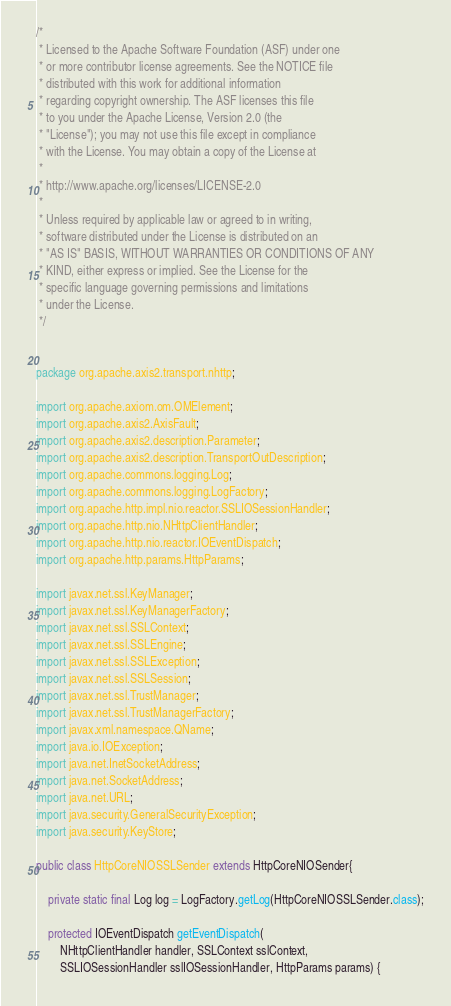<code> <loc_0><loc_0><loc_500><loc_500><_Java_>
/*
 * Licensed to the Apache Software Foundation (ASF) under one
 * or more contributor license agreements. See the NOTICE file
 * distributed with this work for additional information
 * regarding copyright ownership. The ASF licenses this file
 * to you under the Apache License, Version 2.0 (the
 * "License"); you may not use this file except in compliance
 * with the License. You may obtain a copy of the License at
 *
 * http://www.apache.org/licenses/LICENSE-2.0
 *
 * Unless required by applicable law or agreed to in writing,
 * software distributed under the License is distributed on an
 * "AS IS" BASIS, WITHOUT WARRANTIES OR CONDITIONS OF ANY
 * KIND, either express or implied. See the License for the
 * specific language governing permissions and limitations
 * under the License.
 */


package org.apache.axis2.transport.nhttp;

import org.apache.axiom.om.OMElement;
import org.apache.axis2.AxisFault;
import org.apache.axis2.description.Parameter;
import org.apache.axis2.description.TransportOutDescription;
import org.apache.commons.logging.Log;
import org.apache.commons.logging.LogFactory;
import org.apache.http.impl.nio.reactor.SSLIOSessionHandler;
import org.apache.http.nio.NHttpClientHandler;
import org.apache.http.nio.reactor.IOEventDispatch;
import org.apache.http.params.HttpParams;

import javax.net.ssl.KeyManager;
import javax.net.ssl.KeyManagerFactory;
import javax.net.ssl.SSLContext;
import javax.net.ssl.SSLEngine;
import javax.net.ssl.SSLException;
import javax.net.ssl.SSLSession;
import javax.net.ssl.TrustManager;
import javax.net.ssl.TrustManagerFactory;
import javax.xml.namespace.QName;
import java.io.IOException;
import java.net.InetSocketAddress;
import java.net.SocketAddress;
import java.net.URL;
import java.security.GeneralSecurityException;
import java.security.KeyStore;

public class HttpCoreNIOSSLSender extends HttpCoreNIOSender{

    private static final Log log = LogFactory.getLog(HttpCoreNIOSSLSender.class);

    protected IOEventDispatch getEventDispatch(
        NHttpClientHandler handler, SSLContext sslContext,
        SSLIOSessionHandler sslIOSessionHandler, HttpParams params) {</code> 